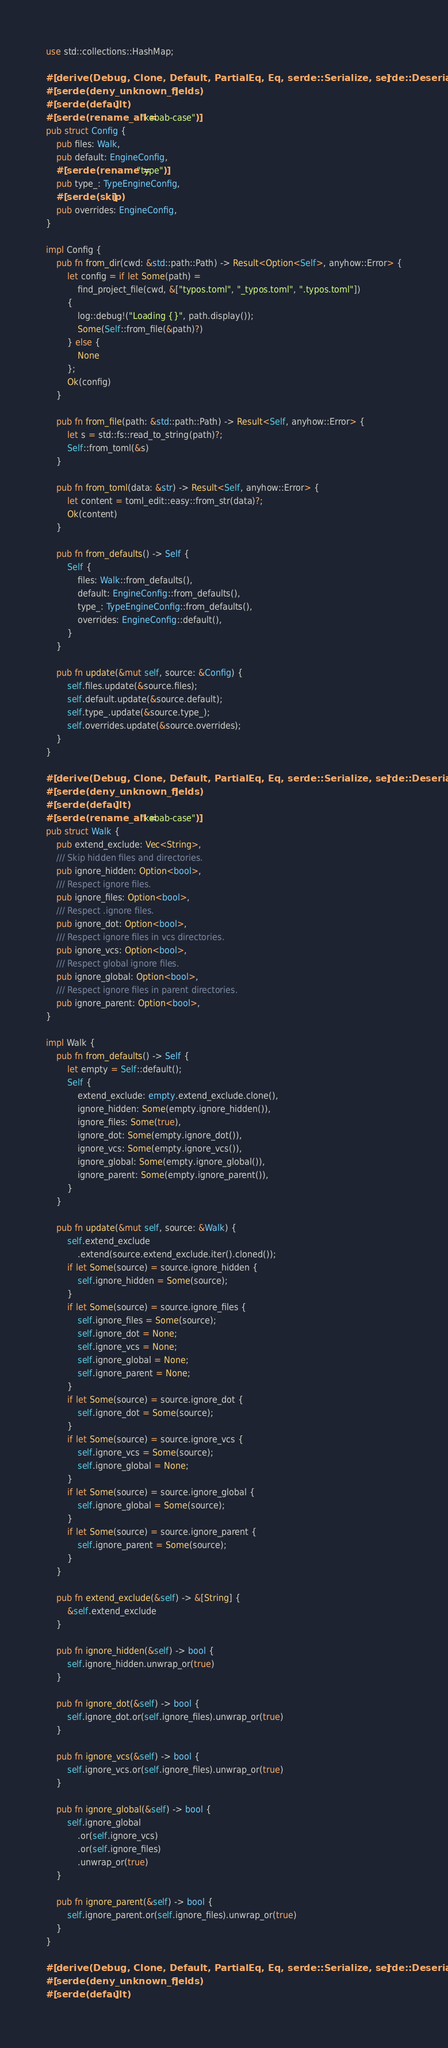<code> <loc_0><loc_0><loc_500><loc_500><_Rust_>use std::collections::HashMap;

#[derive(Debug, Clone, Default, PartialEq, Eq, serde::Serialize, serde::Deserialize)]
#[serde(deny_unknown_fields)]
#[serde(default)]
#[serde(rename_all = "kebab-case")]
pub struct Config {
    pub files: Walk,
    pub default: EngineConfig,
    #[serde(rename = "type")]
    pub type_: TypeEngineConfig,
    #[serde(skip)]
    pub overrides: EngineConfig,
}

impl Config {
    pub fn from_dir(cwd: &std::path::Path) -> Result<Option<Self>, anyhow::Error> {
        let config = if let Some(path) =
            find_project_file(cwd, &["typos.toml", "_typos.toml", ".typos.toml"])
        {
            log::debug!("Loading {}", path.display());
            Some(Self::from_file(&path)?)
        } else {
            None
        };
        Ok(config)
    }

    pub fn from_file(path: &std::path::Path) -> Result<Self, anyhow::Error> {
        let s = std::fs::read_to_string(path)?;
        Self::from_toml(&s)
    }

    pub fn from_toml(data: &str) -> Result<Self, anyhow::Error> {
        let content = toml_edit::easy::from_str(data)?;
        Ok(content)
    }

    pub fn from_defaults() -> Self {
        Self {
            files: Walk::from_defaults(),
            default: EngineConfig::from_defaults(),
            type_: TypeEngineConfig::from_defaults(),
            overrides: EngineConfig::default(),
        }
    }

    pub fn update(&mut self, source: &Config) {
        self.files.update(&source.files);
        self.default.update(&source.default);
        self.type_.update(&source.type_);
        self.overrides.update(&source.overrides);
    }
}

#[derive(Debug, Clone, Default, PartialEq, Eq, serde::Serialize, serde::Deserialize)]
#[serde(deny_unknown_fields)]
#[serde(default)]
#[serde(rename_all = "kebab-case")]
pub struct Walk {
    pub extend_exclude: Vec<String>,
    /// Skip hidden files and directories.
    pub ignore_hidden: Option<bool>,
    /// Respect ignore files.
    pub ignore_files: Option<bool>,
    /// Respect .ignore files.
    pub ignore_dot: Option<bool>,
    /// Respect ignore files in vcs directories.
    pub ignore_vcs: Option<bool>,
    /// Respect global ignore files.
    pub ignore_global: Option<bool>,
    /// Respect ignore files in parent directories.
    pub ignore_parent: Option<bool>,
}

impl Walk {
    pub fn from_defaults() -> Self {
        let empty = Self::default();
        Self {
            extend_exclude: empty.extend_exclude.clone(),
            ignore_hidden: Some(empty.ignore_hidden()),
            ignore_files: Some(true),
            ignore_dot: Some(empty.ignore_dot()),
            ignore_vcs: Some(empty.ignore_vcs()),
            ignore_global: Some(empty.ignore_global()),
            ignore_parent: Some(empty.ignore_parent()),
        }
    }

    pub fn update(&mut self, source: &Walk) {
        self.extend_exclude
            .extend(source.extend_exclude.iter().cloned());
        if let Some(source) = source.ignore_hidden {
            self.ignore_hidden = Some(source);
        }
        if let Some(source) = source.ignore_files {
            self.ignore_files = Some(source);
            self.ignore_dot = None;
            self.ignore_vcs = None;
            self.ignore_global = None;
            self.ignore_parent = None;
        }
        if let Some(source) = source.ignore_dot {
            self.ignore_dot = Some(source);
        }
        if let Some(source) = source.ignore_vcs {
            self.ignore_vcs = Some(source);
            self.ignore_global = None;
        }
        if let Some(source) = source.ignore_global {
            self.ignore_global = Some(source);
        }
        if let Some(source) = source.ignore_parent {
            self.ignore_parent = Some(source);
        }
    }

    pub fn extend_exclude(&self) -> &[String] {
        &self.extend_exclude
    }

    pub fn ignore_hidden(&self) -> bool {
        self.ignore_hidden.unwrap_or(true)
    }

    pub fn ignore_dot(&self) -> bool {
        self.ignore_dot.or(self.ignore_files).unwrap_or(true)
    }

    pub fn ignore_vcs(&self) -> bool {
        self.ignore_vcs.or(self.ignore_files).unwrap_or(true)
    }

    pub fn ignore_global(&self) -> bool {
        self.ignore_global
            .or(self.ignore_vcs)
            .or(self.ignore_files)
            .unwrap_or(true)
    }

    pub fn ignore_parent(&self) -> bool {
        self.ignore_parent.or(self.ignore_files).unwrap_or(true)
    }
}

#[derive(Debug, Clone, Default, PartialEq, Eq, serde::Serialize, serde::Deserialize)]
#[serde(deny_unknown_fields)]
#[serde(default)]</code> 